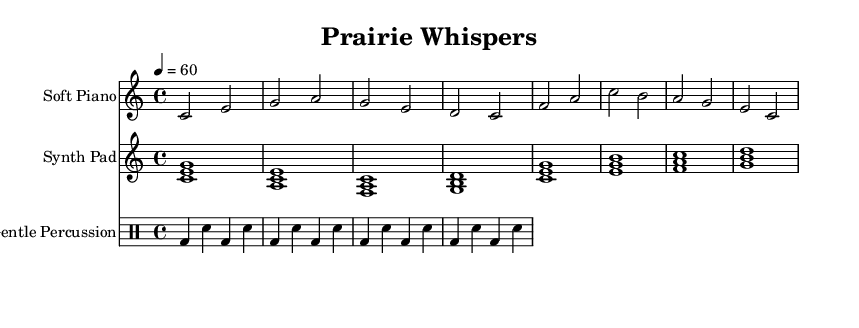What is the title of this piece? The title is located in the header section of the sheet music, clearly stated as "Prairie Whispers."
Answer: Prairie Whispers What is the key signature of this music? The key signature is indicated by the symbol at the beginning of the score, which shows that it is in C major, having no sharps or flats.
Answer: C major What is the time signature of this piece? The time signature is found next to the key signature at the beginning of the score, specified as 4/4.
Answer: 4/4 What is the tempo marking of the music? The tempo marking is located below the time signature, reading "4 = 60," which indicates the speed of the music.
Answer: 60 How many measures does the soft piano part contain? By counting the individual measures in the soft piano staff, there are eight distinct measures represented.
Answer: 8 What does the synth pad consist of in this piece? The synth pad is notated using chords, represented by stacked notes in the score, which outlines major chords related to the piece's harmonic structure.
Answer: Chords What kind of percussion is used in this composition? The percussion part is denoted using a drum notation method, which specifies the use of bass drum (bd) and snare drum (sn) in a gentle alternating rhythm.
Answer: Gentle percussion 